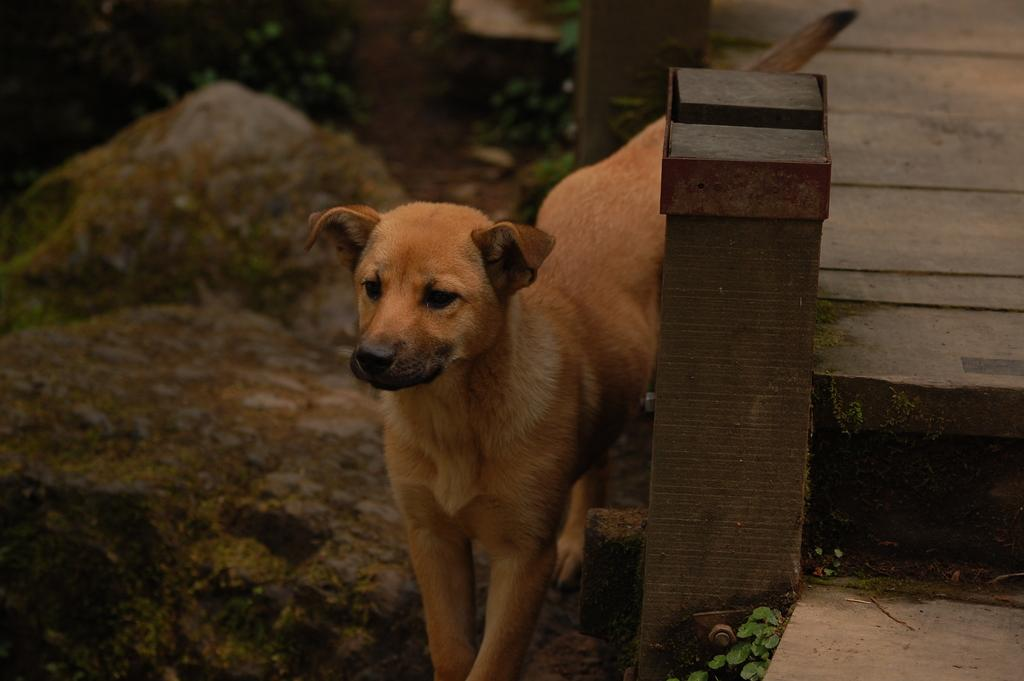What animal is standing in the image? There is a dog standing in the image. What can be seen on the right side of the image? There are plants, a pole, and a walkway on the right side of the image. What is visible in the background of the image? There are stones, plants, and a pole in the background of the image. What type of test is being conducted on the dog in the image? There is no test being conducted on the dog in the image; it is simply standing. How many tickets are visible in the image? There are no tickets present in the image. 